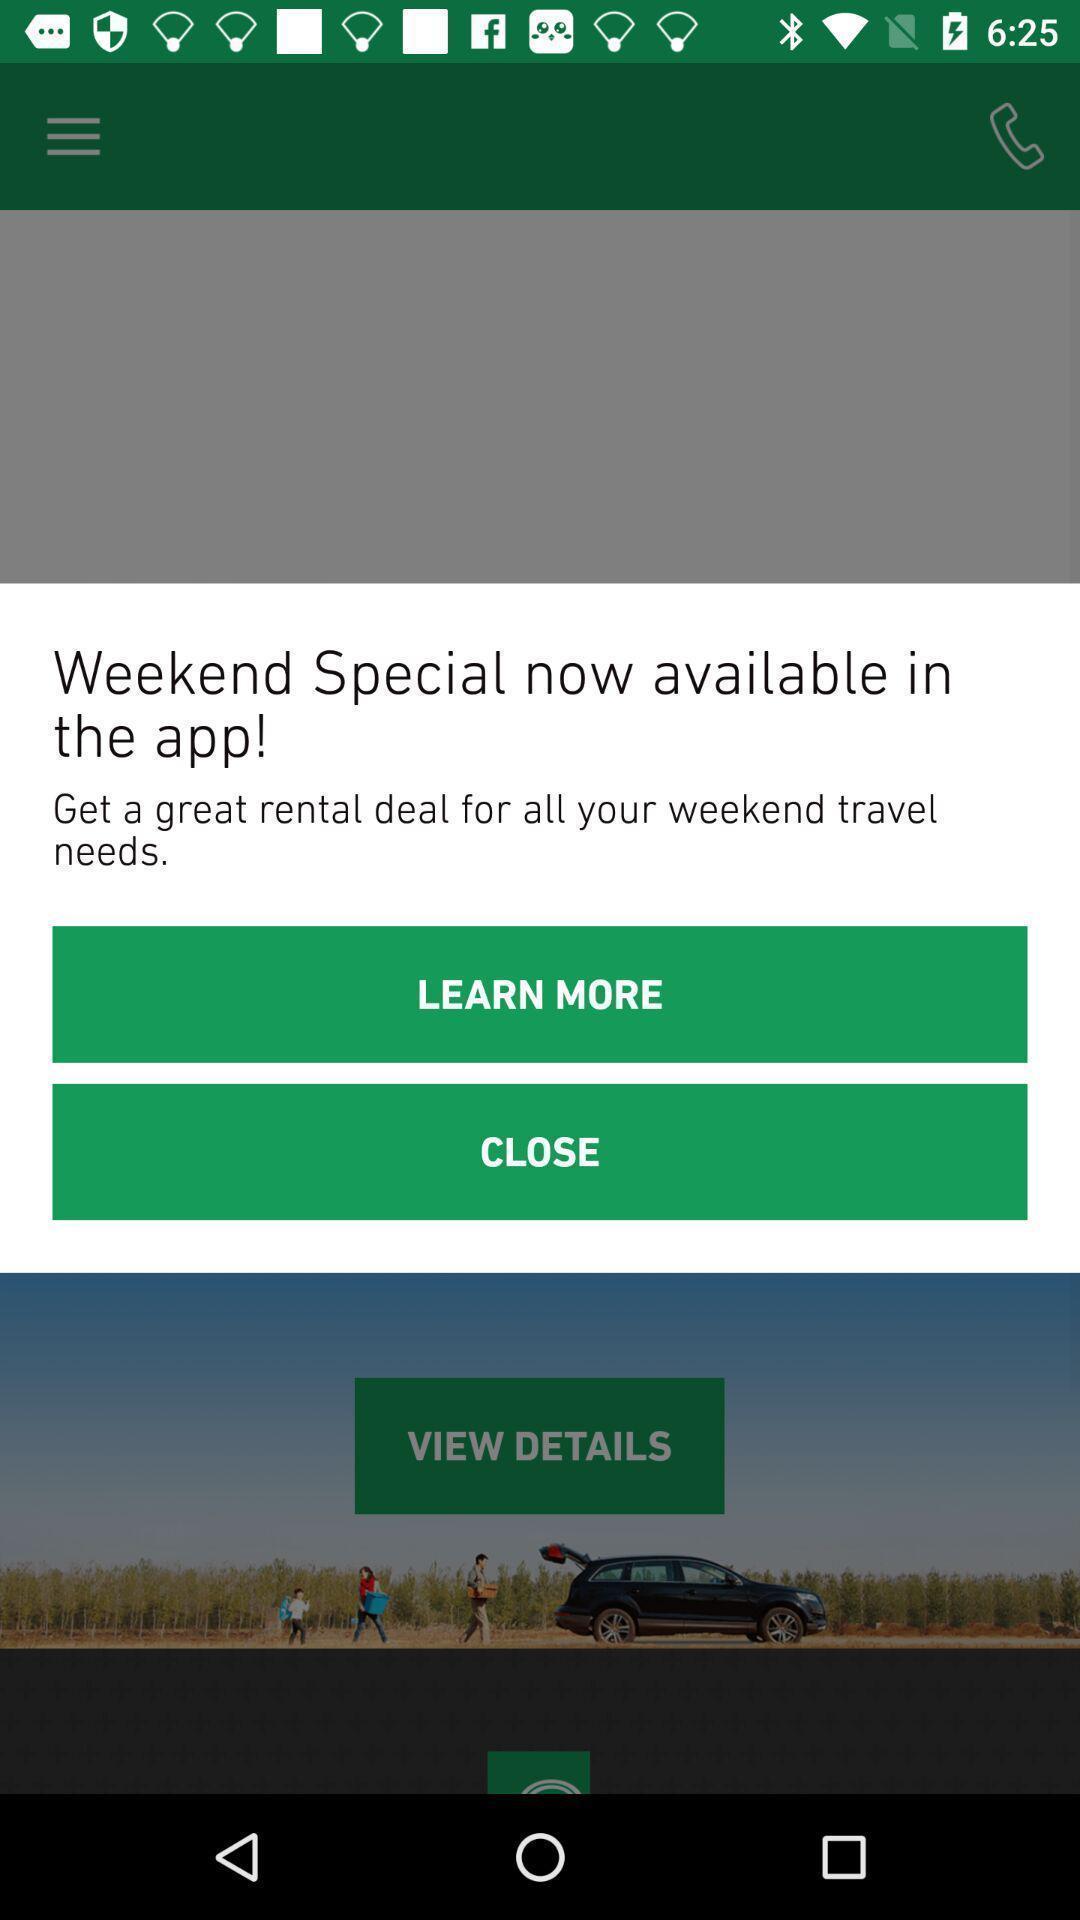Give me a summary of this screen capture. Pop up showing weekend special rental deal. 